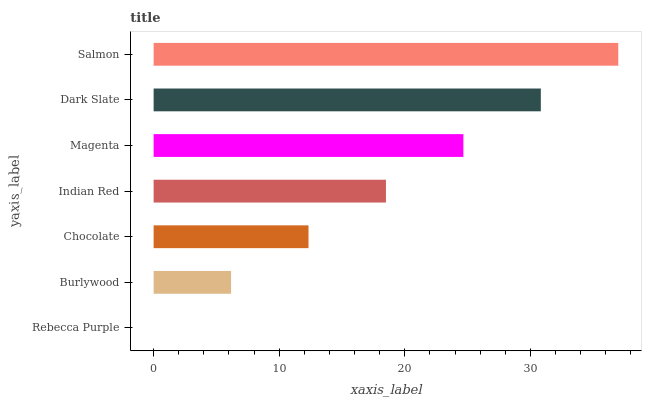Is Rebecca Purple the minimum?
Answer yes or no. Yes. Is Salmon the maximum?
Answer yes or no. Yes. Is Burlywood the minimum?
Answer yes or no. No. Is Burlywood the maximum?
Answer yes or no. No. Is Burlywood greater than Rebecca Purple?
Answer yes or no. Yes. Is Rebecca Purple less than Burlywood?
Answer yes or no. Yes. Is Rebecca Purple greater than Burlywood?
Answer yes or no. No. Is Burlywood less than Rebecca Purple?
Answer yes or no. No. Is Indian Red the high median?
Answer yes or no. Yes. Is Indian Red the low median?
Answer yes or no. Yes. Is Dark Slate the high median?
Answer yes or no. No. Is Burlywood the low median?
Answer yes or no. No. 